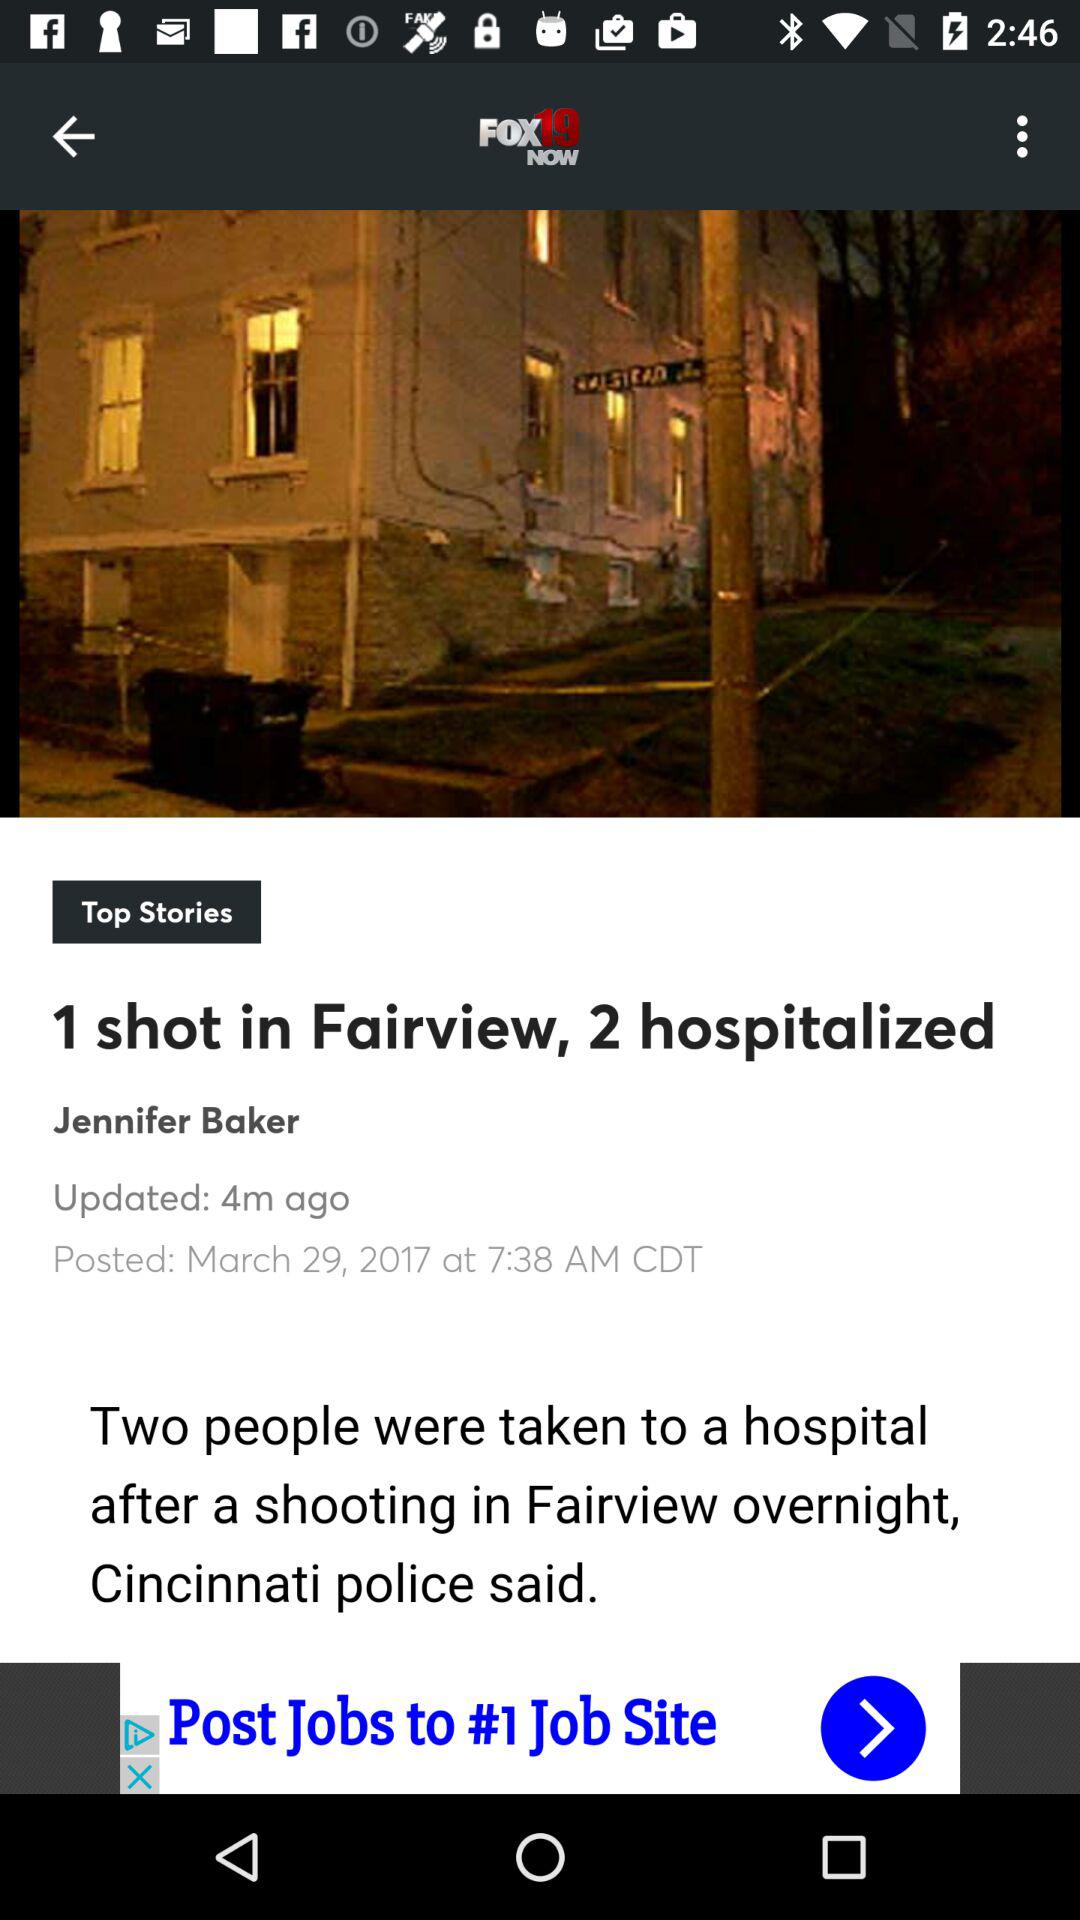What is the name of the application? The name of the application is "FOX19 NOW". 